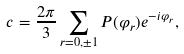<formula> <loc_0><loc_0><loc_500><loc_500>c = \frac { 2 \pi } { 3 } \sum _ { r = 0 , \pm 1 } P ( \varphi _ { r } ) e ^ { - i \varphi _ { r } } ,</formula> 